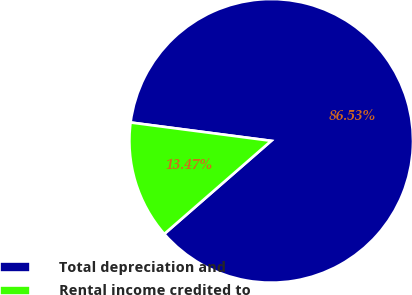Convert chart to OTSL. <chart><loc_0><loc_0><loc_500><loc_500><pie_chart><fcel>Total depreciation and<fcel>Rental income credited to<nl><fcel>86.53%<fcel>13.47%<nl></chart> 